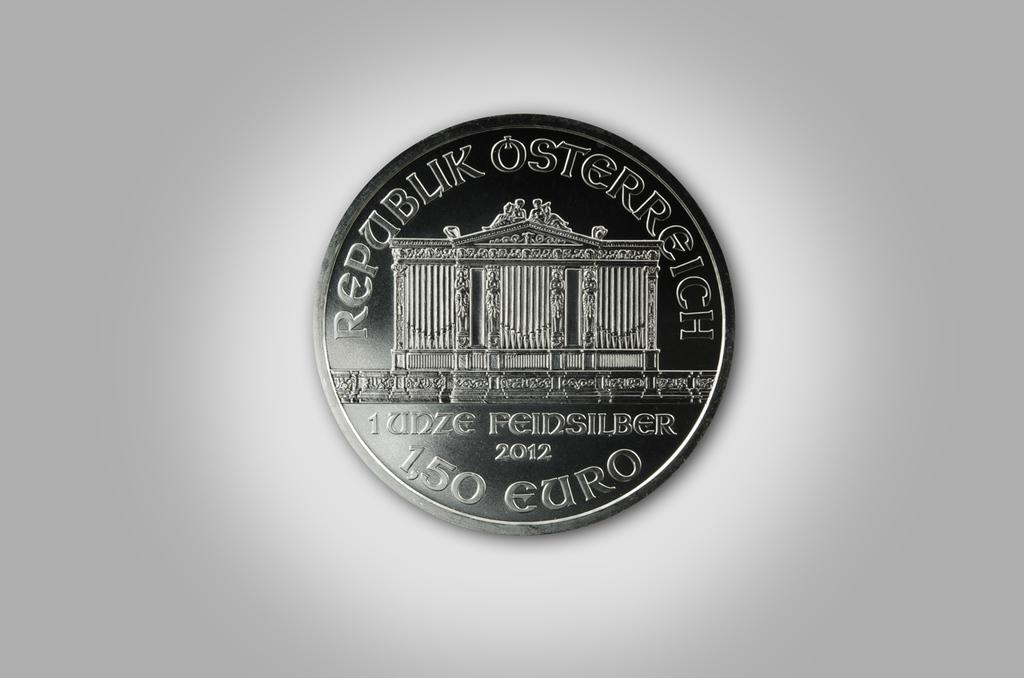Provide a one-sentence caption for the provided image. A foreign coin made in 2012 has the value of 1.50 Euro. 